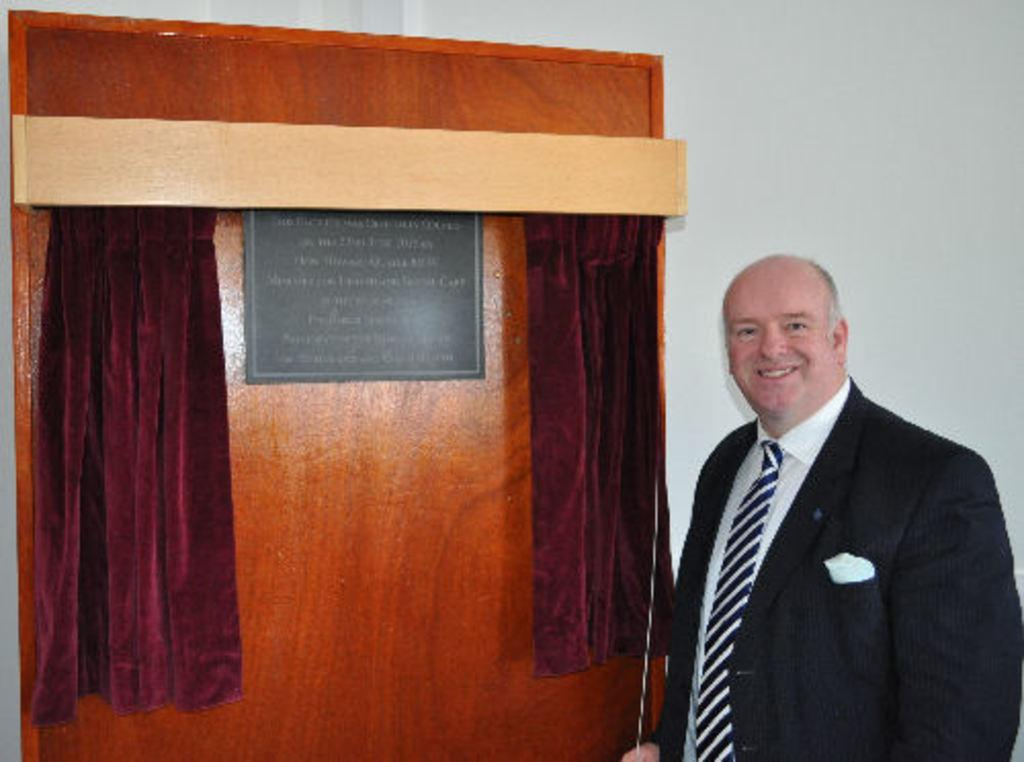What is the person in the image wearing? The person is wearing a black suit in the image. Where is the person located in the image? The person is standing in the right corner of the image. What is beside the person in the image? There is a board with writing on it beside the person. What can be seen on either side of the board in the image? There are curtains on either side of the board. What type of box is being used for treatment in the image? There is no box or treatment present in the image. What type of trade is being conducted in the image? There is no trade being conducted in the image. 